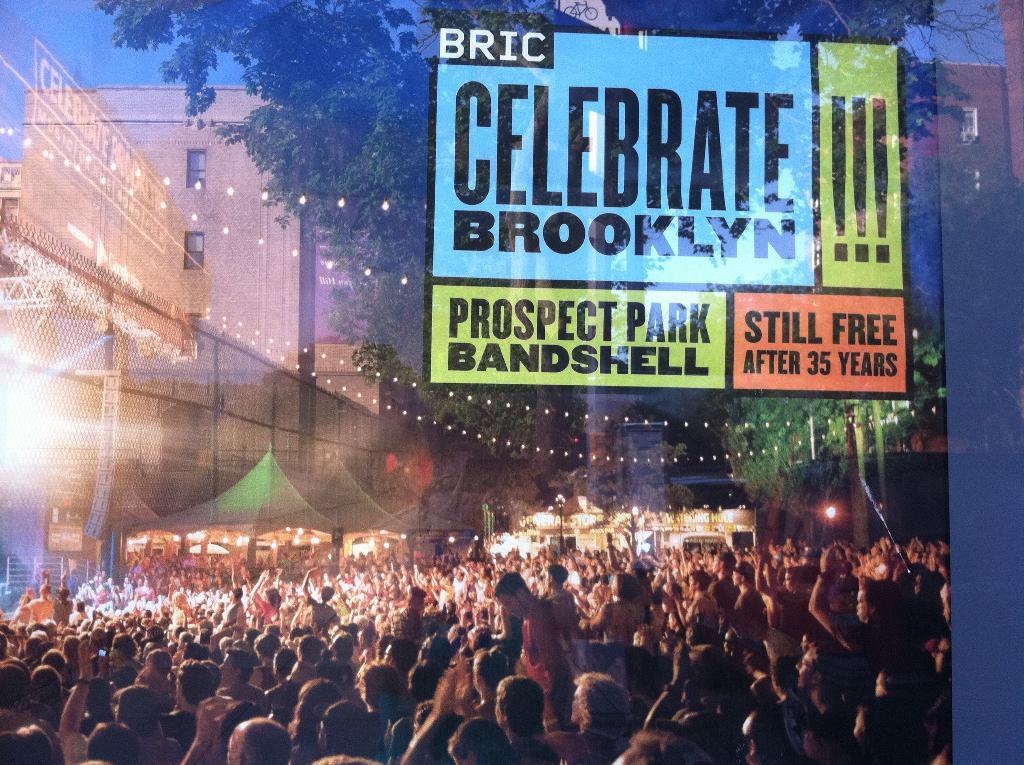Who are we celebrating?
Your response must be concise. Brooklyn. Where will this event be held?
Your response must be concise. Brooklyn. 